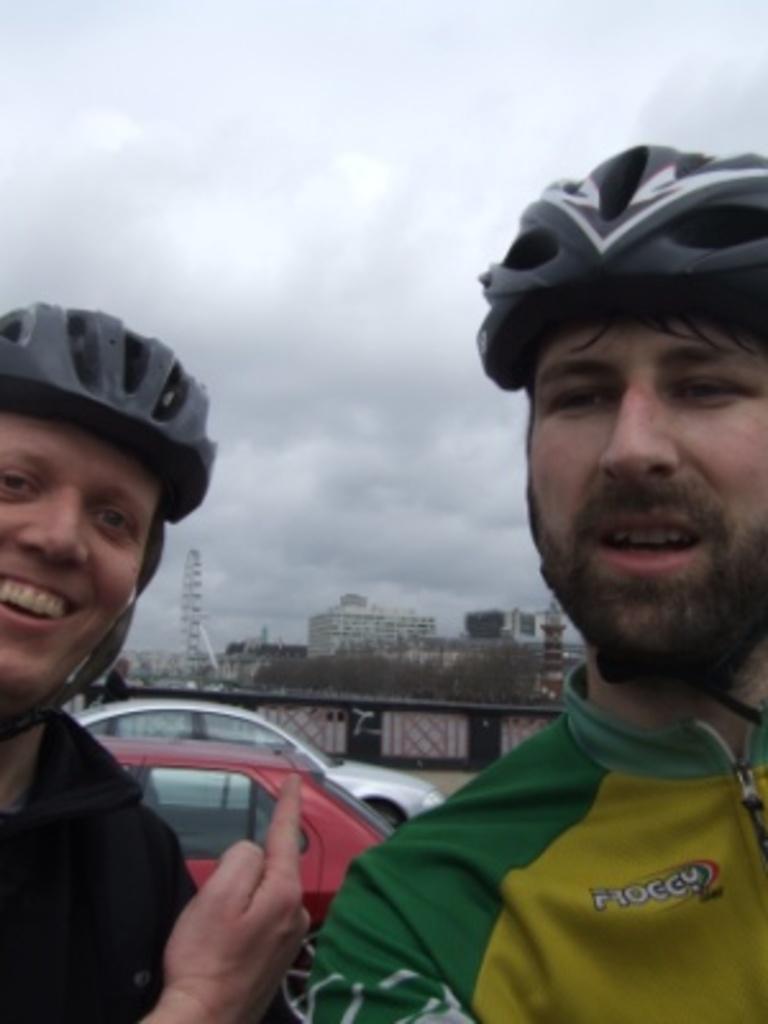How would you summarize this image in a sentence or two? On the left side, there is a person wearing a helmet, smiling and showing a finger. On the right side, there is a person wearing a helmet and speaking. In the background, there are vehicles, buildings, a giant wheel, trees and there are clouds in the sky. 